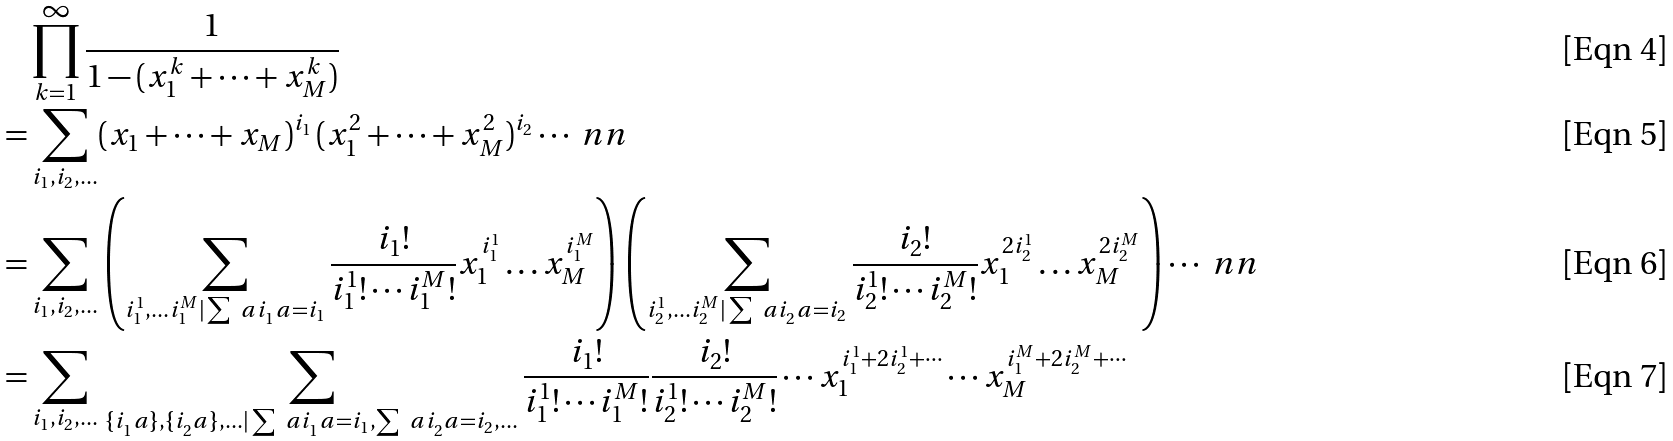<formula> <loc_0><loc_0><loc_500><loc_500>& \prod _ { k = 1 } ^ { \infty } \frac { 1 } { 1 - ( x _ { 1 } ^ { k } + \cdots + x _ { M } ^ { k } ) } \\ = & \sum _ { i _ { 1 } , i _ { 2 } , \dots } ( x _ { 1 } + \cdots + x _ { M } ) ^ { i _ { 1 } } \, ( x _ { 1 } ^ { 2 } + \cdots + x _ { M } ^ { 2 } ) ^ { i _ { 2 } } \cdots \ n n \\ = & \sum _ { i _ { 1 } , i _ { 2 } , \dots } \left ( \sum _ { i _ { 1 } ^ { 1 } , \dots i _ { 1 } ^ { M } | \sum _ { \ } a i _ { 1 } ^ { \ } a = i _ { 1 } } \frac { i _ { 1 } ! } { i _ { 1 } ^ { 1 } ! \cdots i _ { 1 } ^ { M } ! } x _ { 1 } ^ { i _ { 1 } ^ { 1 } } \dots x _ { M } ^ { i _ { 1 } ^ { M } } \right ) \left ( \sum _ { i _ { 2 } ^ { 1 } , \dots i _ { 2 } ^ { M } | \sum _ { \ } a i _ { 2 } ^ { \ } a = i _ { 2 } } \frac { i _ { 2 } ! } { i _ { 2 } ^ { 1 } ! \cdots i _ { 2 } ^ { M } ! } x _ { 1 } ^ { 2 i _ { 2 } ^ { 1 } } \dots x _ { M } ^ { 2 i _ { 2 } ^ { M } } \right ) \cdots \ n n \\ = & \sum _ { i _ { 1 } , i _ { 2 } , \dots } \, \sum _ { \{ i _ { 1 } ^ { \ } a \} , \{ i _ { 2 } ^ { \ } a \} , \dots | \sum _ { \ } a i _ { 1 } ^ { \ } a = i _ { 1 } , \sum _ { \ } a i _ { 2 } ^ { \ } a = i _ { 2 } , \dots } \frac { i _ { 1 } ! } { i _ { 1 } ^ { 1 } ! \cdots i _ { 1 } ^ { M } ! } \frac { i _ { 2 } ! } { i _ { 2 } ^ { 1 } ! \cdots i _ { 2 } ^ { M } ! } \cdots x _ { 1 } ^ { i _ { 1 } ^ { 1 } + 2 i _ { 2 } ^ { 1 } + \cdots } \cdots x _ { M } ^ { i _ { 1 } ^ { M } + 2 i _ { 2 } ^ { M } + \cdots }</formula> 